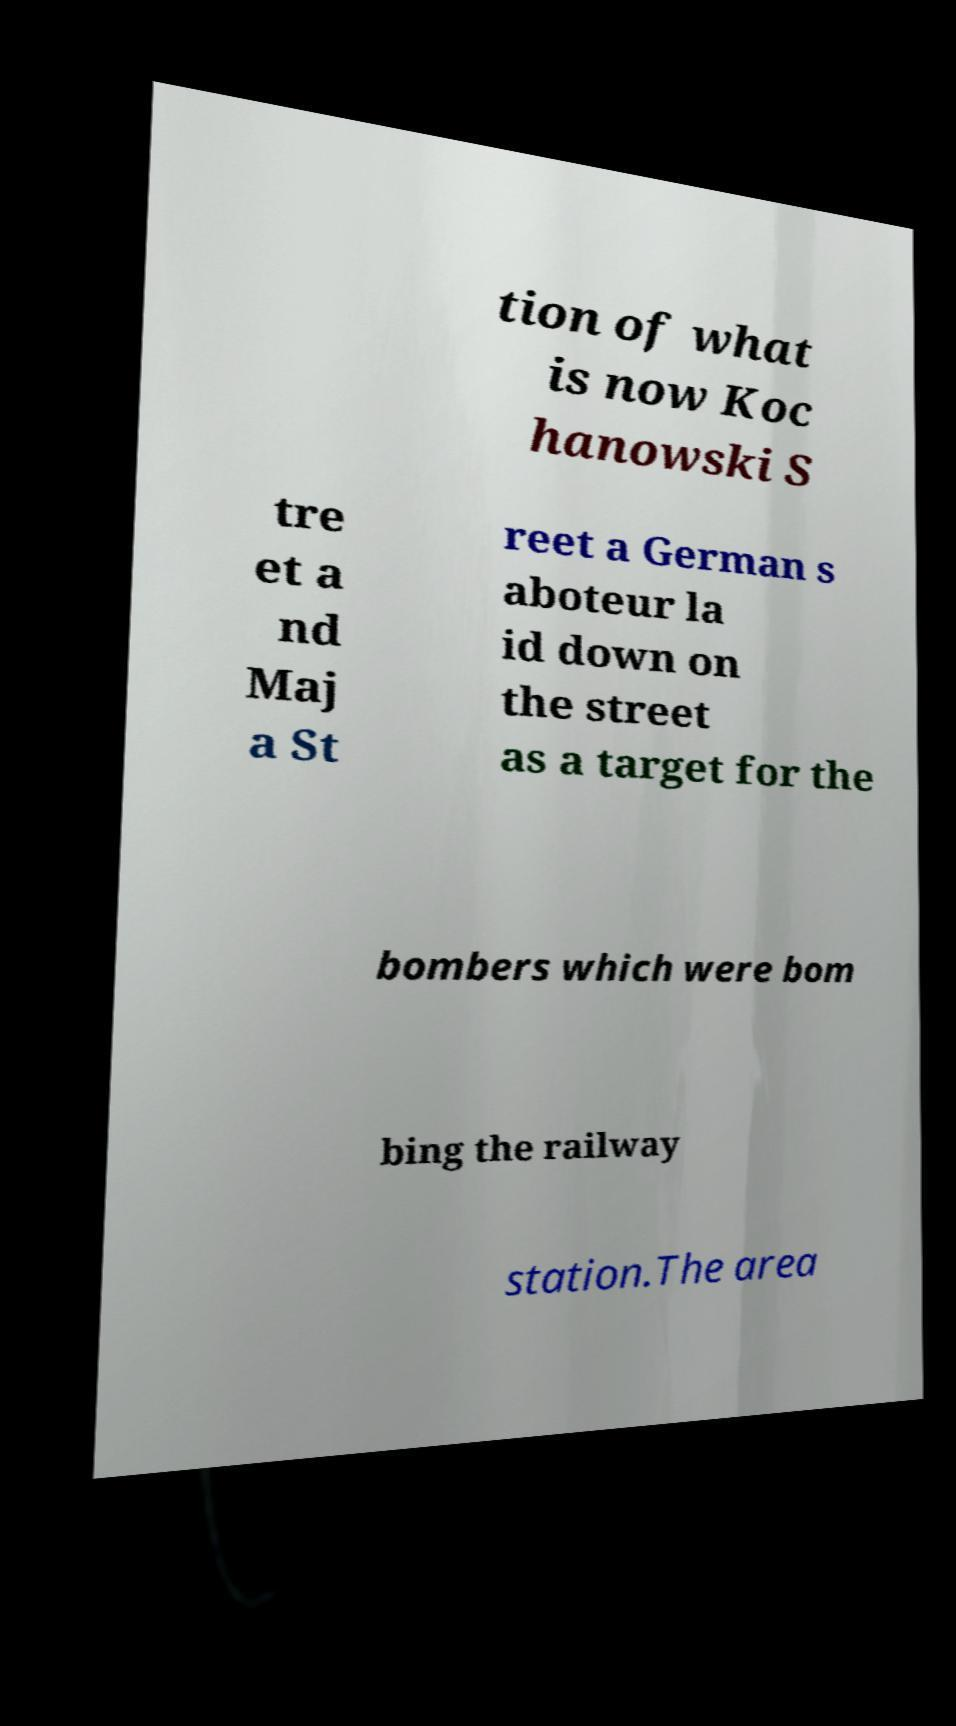For documentation purposes, I need the text within this image transcribed. Could you provide that? tion of what is now Koc hanowski S tre et a nd Maj a St reet a German s aboteur la id down on the street as a target for the bombers which were bom bing the railway station.The area 